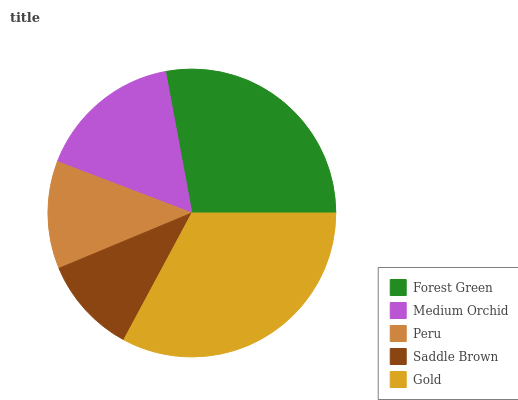Is Saddle Brown the minimum?
Answer yes or no. Yes. Is Gold the maximum?
Answer yes or no. Yes. Is Medium Orchid the minimum?
Answer yes or no. No. Is Medium Orchid the maximum?
Answer yes or no. No. Is Forest Green greater than Medium Orchid?
Answer yes or no. Yes. Is Medium Orchid less than Forest Green?
Answer yes or no. Yes. Is Medium Orchid greater than Forest Green?
Answer yes or no. No. Is Forest Green less than Medium Orchid?
Answer yes or no. No. Is Medium Orchid the high median?
Answer yes or no. Yes. Is Medium Orchid the low median?
Answer yes or no. Yes. Is Peru the high median?
Answer yes or no. No. Is Forest Green the low median?
Answer yes or no. No. 